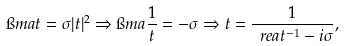Convert formula to latex. <formula><loc_0><loc_0><loc_500><loc_500>\i m a t = \sigma | t | ^ { 2 } \Rightarrow \i m a \frac { 1 } { t } = - \sigma \Rightarrow t = \frac { 1 } { \ r e a t ^ { - 1 } - i \sigma } ,</formula> 